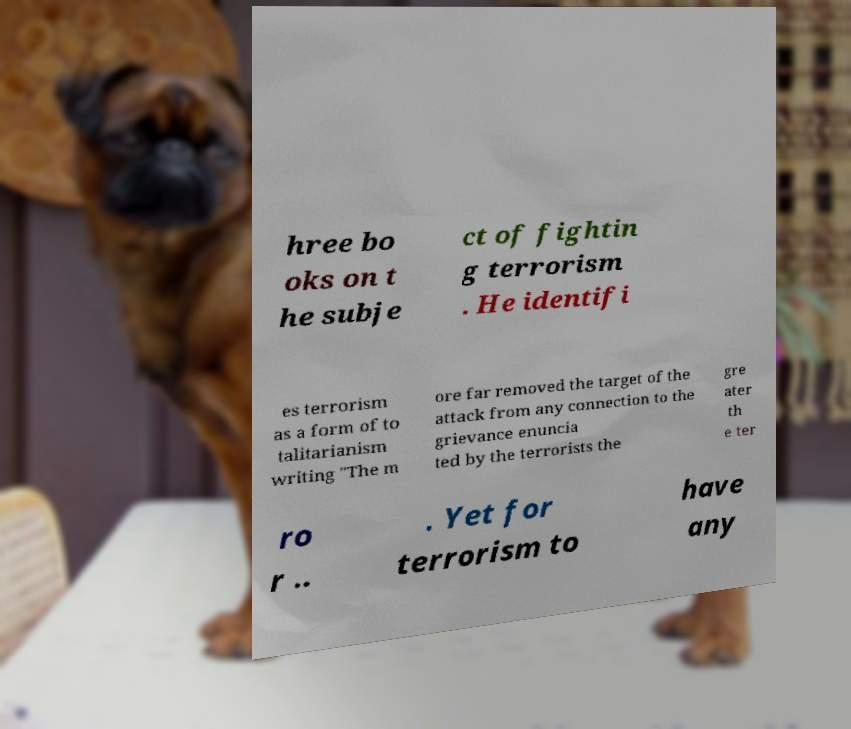What messages or text are displayed in this image? I need them in a readable, typed format. hree bo oks on t he subje ct of fightin g terrorism . He identifi es terrorism as a form of to talitarianism writing "The m ore far removed the target of the attack from any connection to the grievance enuncia ted by the terrorists the gre ater th e ter ro r .. . Yet for terrorism to have any 